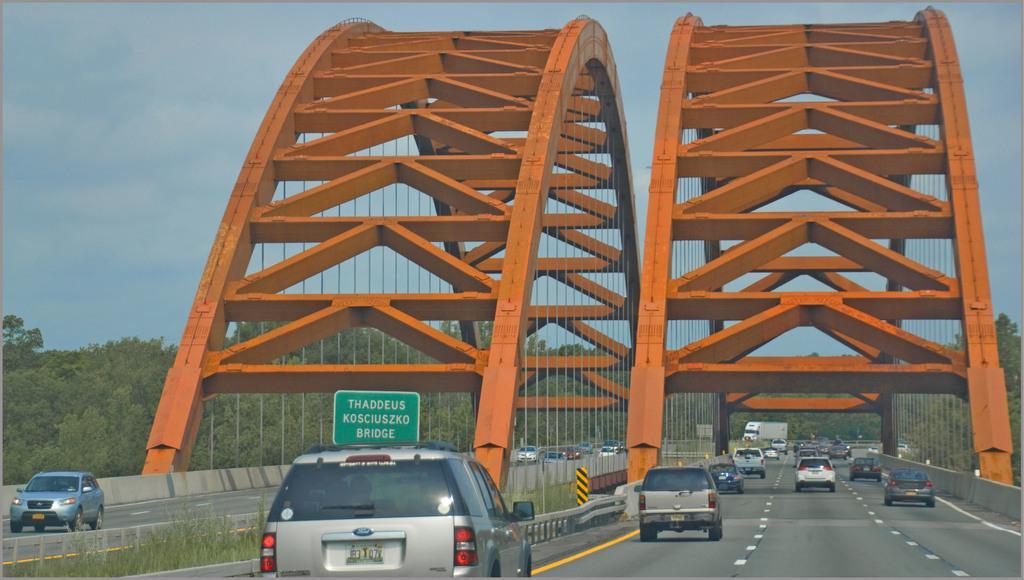In one or two sentences, can you explain what this image depicts? In this picture I can observe some cars moving on the bridges. These bridges are looking like an arch bridges. In the background there are trees and sky. 